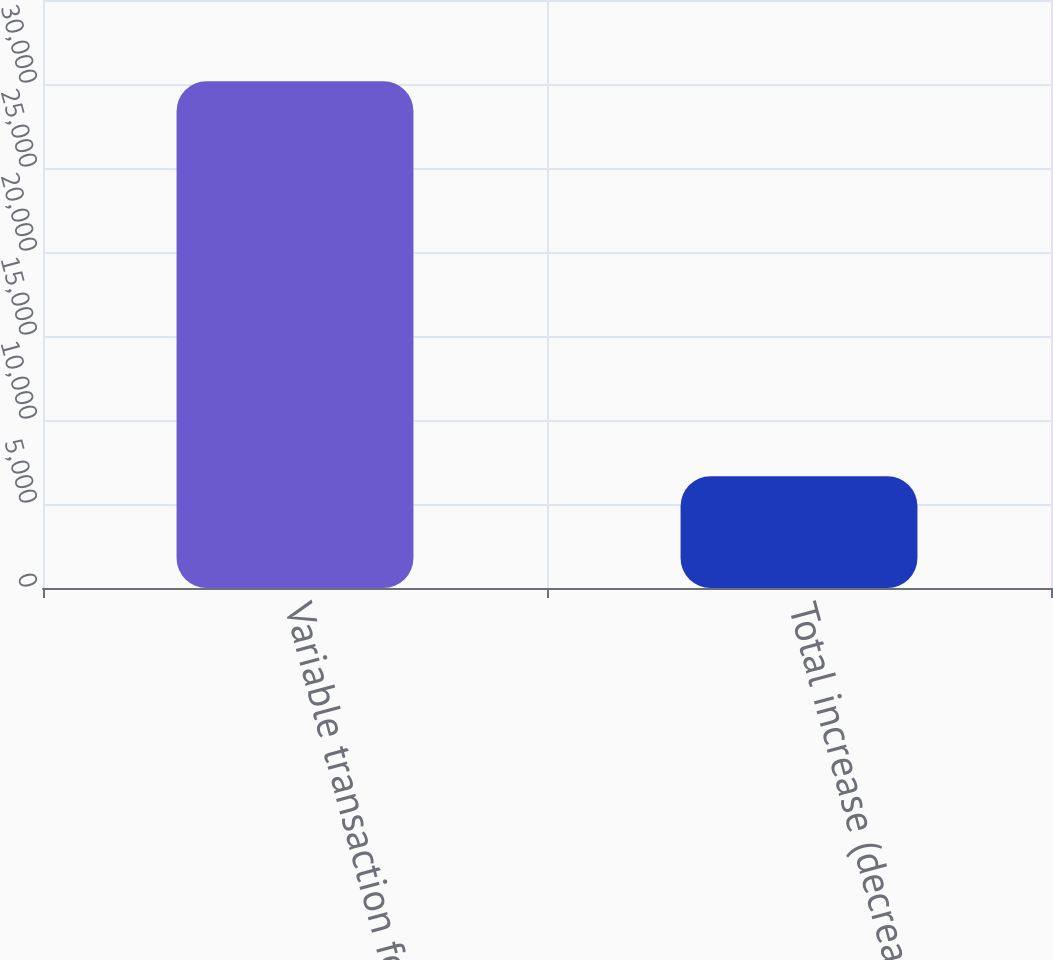<chart> <loc_0><loc_0><loc_500><loc_500><bar_chart><fcel>Variable transaction fee per<fcel>Total increase (decrease) in<nl><fcel>30162<fcel>6656<nl></chart> 